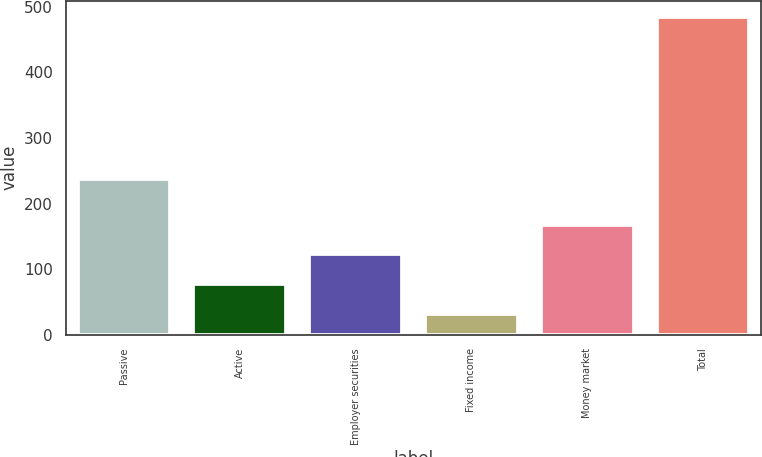Convert chart to OTSL. <chart><loc_0><loc_0><loc_500><loc_500><bar_chart><fcel>Passive<fcel>Active<fcel>Employer securities<fcel>Fixed income<fcel>Money market<fcel>Total<nl><fcel>237<fcel>77.3<fcel>122.6<fcel>32<fcel>167.9<fcel>485<nl></chart> 